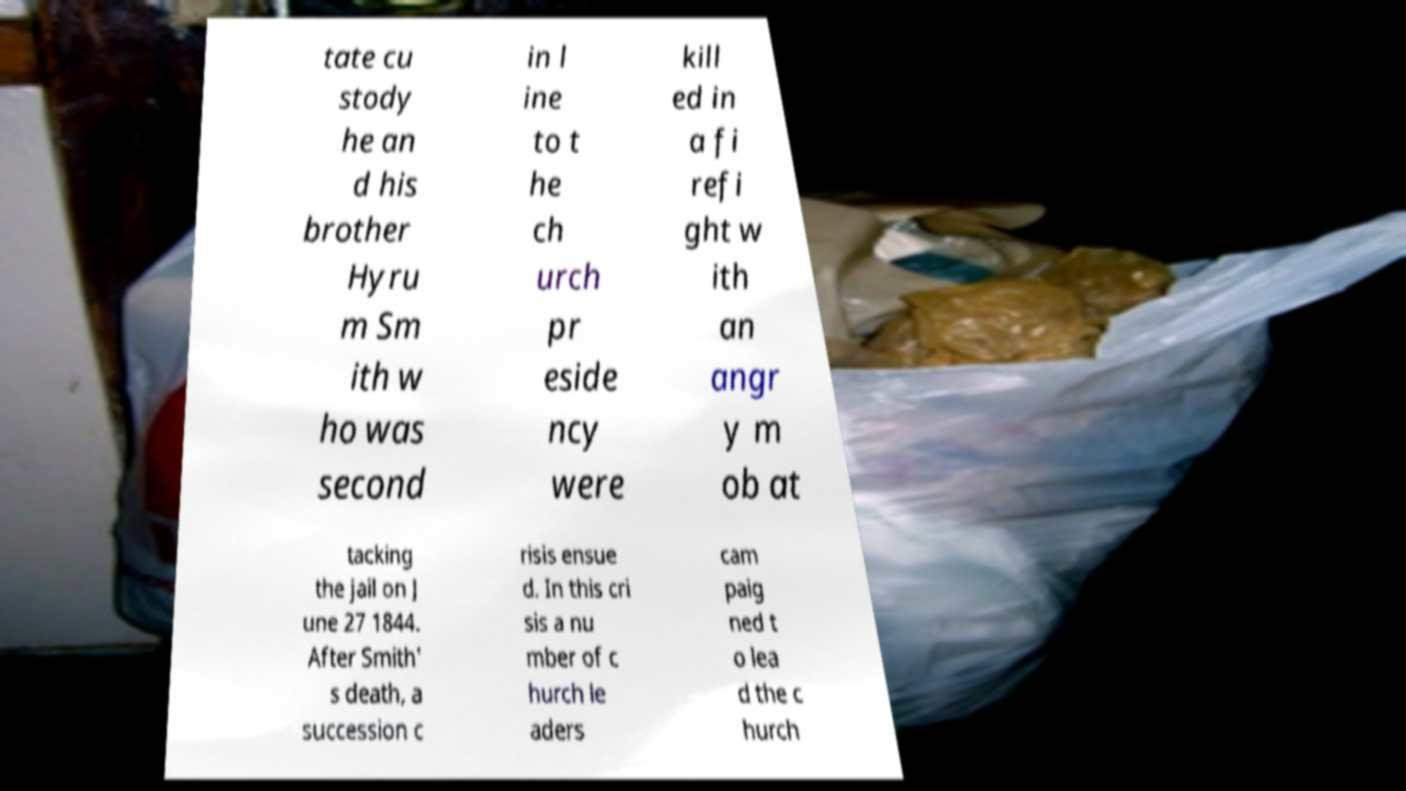Can you accurately transcribe the text from the provided image for me? tate cu stody he an d his brother Hyru m Sm ith w ho was second in l ine to t he ch urch pr eside ncy were kill ed in a fi refi ght w ith an angr y m ob at tacking the jail on J une 27 1844. After Smith' s death, a succession c risis ensue d. In this cri sis a nu mber of c hurch le aders cam paig ned t o lea d the c hurch 